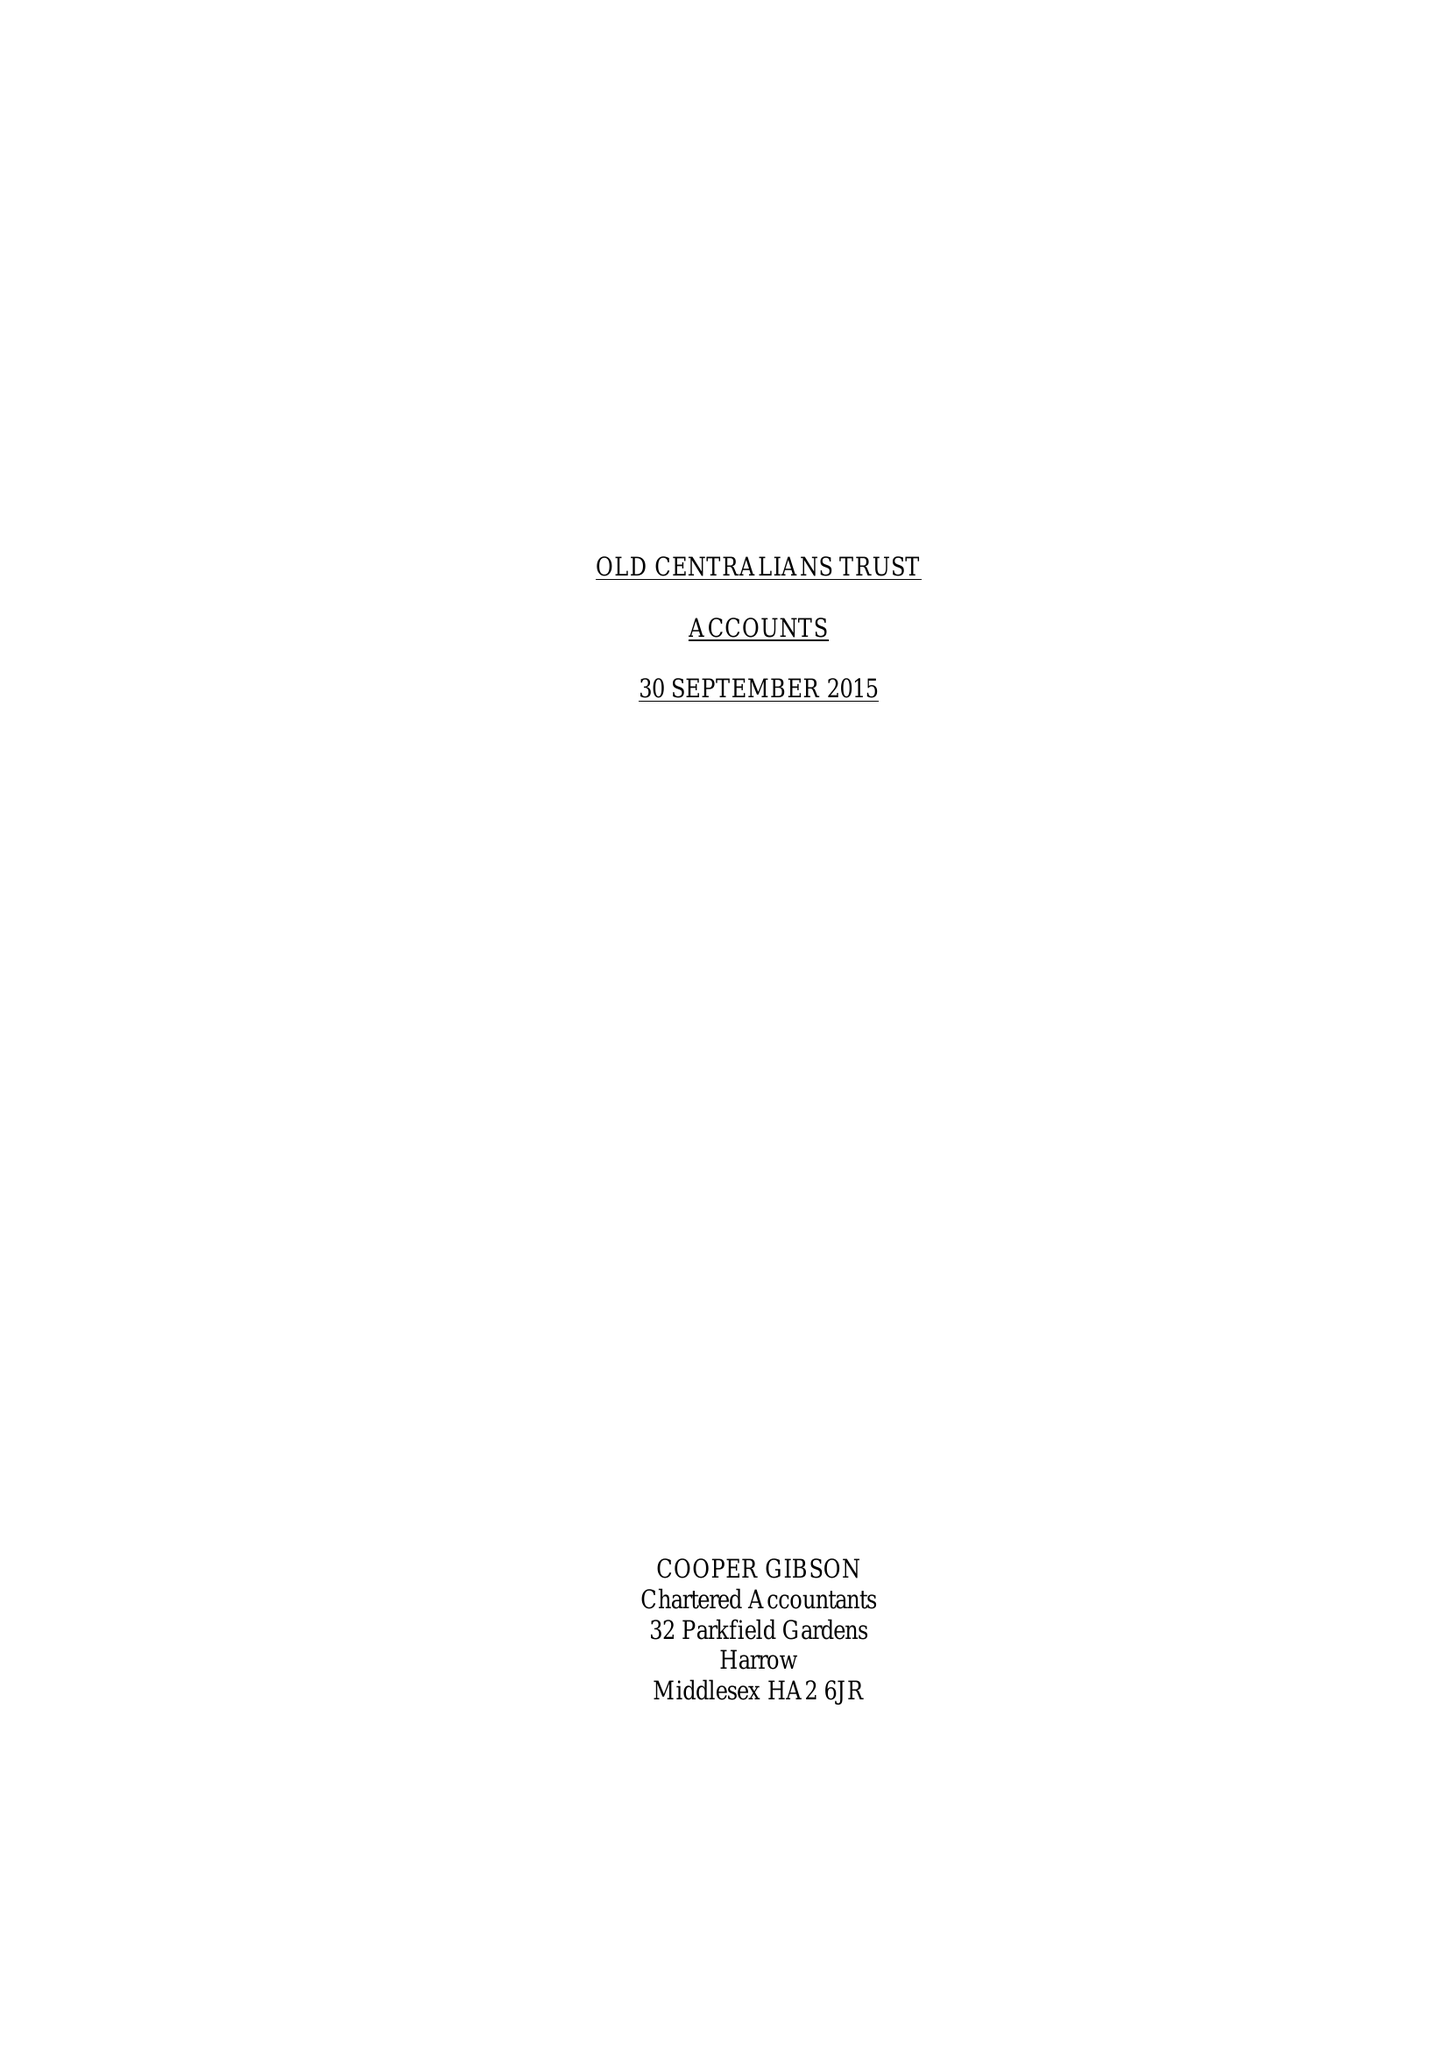What is the value for the spending_annually_in_british_pounds?
Answer the question using a single word or phrase. 46420.00 